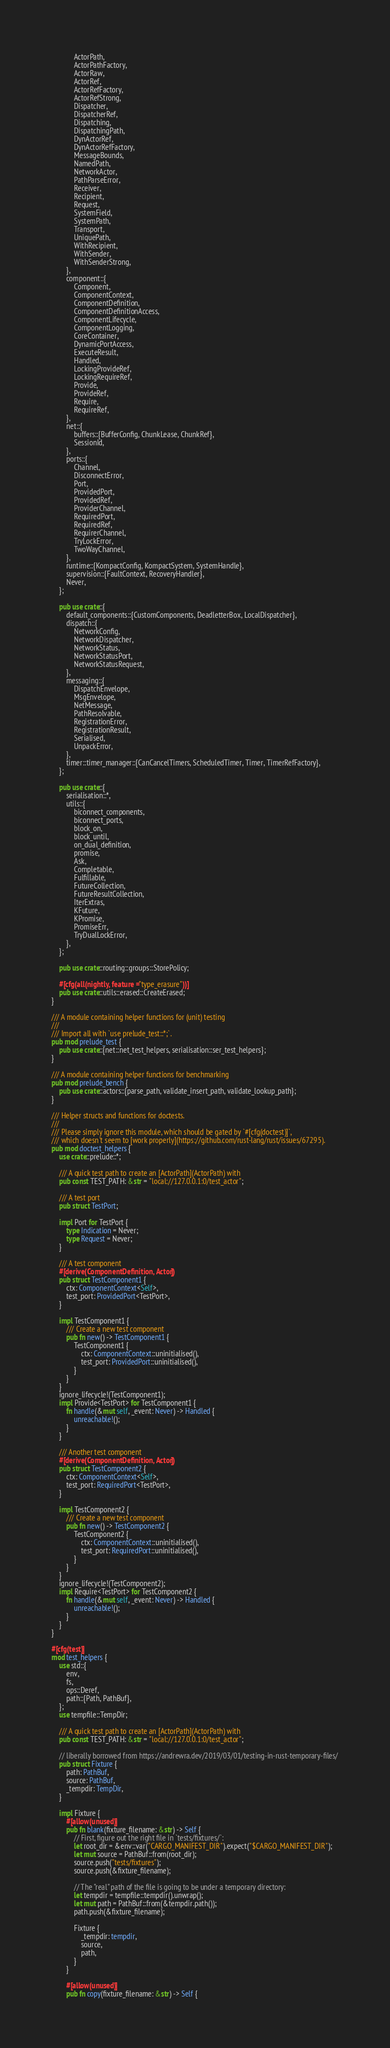<code> <loc_0><loc_0><loc_500><loc_500><_Rust_>            ActorPath,
            ActorPathFactory,
            ActorRaw,
            ActorRef,
            ActorRefFactory,
            ActorRefStrong,
            Dispatcher,
            DispatcherRef,
            Dispatching,
            DispatchingPath,
            DynActorRef,
            DynActorRefFactory,
            MessageBounds,
            NamedPath,
            NetworkActor,
            PathParseError,
            Receiver,
            Recipient,
            Request,
            SystemField,
            SystemPath,
            Transport,
            UniquePath,
            WithRecipient,
            WithSender,
            WithSenderStrong,
        },
        component::{
            Component,
            ComponentContext,
            ComponentDefinition,
            ComponentDefinitionAccess,
            ComponentLifecycle,
            ComponentLogging,
            CoreContainer,
            DynamicPortAccess,
            ExecuteResult,
            Handled,
            LockingProvideRef,
            LockingRequireRef,
            Provide,
            ProvideRef,
            Require,
            RequireRef,
        },
        net::{
            buffers::{BufferConfig, ChunkLease, ChunkRef},
            SessionId,
        },
        ports::{
            Channel,
            DisconnectError,
            Port,
            ProvidedPort,
            ProvidedRef,
            ProviderChannel,
            RequiredPort,
            RequiredRef,
            RequirerChannel,
            TryLockError,
            TwoWayChannel,
        },
        runtime::{KompactConfig, KompactSystem, SystemHandle},
        supervision::{FaultContext, RecoveryHandler},
        Never,
    };

    pub use crate::{
        default_components::{CustomComponents, DeadletterBox, LocalDispatcher},
        dispatch::{
            NetworkConfig,
            NetworkDispatcher,
            NetworkStatus,
            NetworkStatusPort,
            NetworkStatusRequest,
        },
        messaging::{
            DispatchEnvelope,
            MsgEnvelope,
            NetMessage,
            PathResolvable,
            RegistrationError,
            RegistrationResult,
            Serialised,
            UnpackError,
        },
        timer::timer_manager::{CanCancelTimers, ScheduledTimer, Timer, TimerRefFactory},
    };

    pub use crate::{
        serialisation::*,
        utils::{
            biconnect_components,
            biconnect_ports,
            block_on,
            block_until,
            on_dual_definition,
            promise,
            Ask,
            Completable,
            Fulfillable,
            FutureCollection,
            FutureResultCollection,
            IterExtras,
            KFuture,
            KPromise,
            PromiseErr,
            TryDualLockError,
        },
    };

    pub use crate::routing::groups::StorePolicy;

    #[cfg(all(nightly, feature = "type_erasure"))]
    pub use crate::utils::erased::CreateErased;
}

/// A module containing helper functions for (unit) testing
///
/// Import all with `use prelude_test::*;`.
pub mod prelude_test {
    pub use crate::{net::net_test_helpers, serialisation::ser_test_helpers};
}

/// A module containing helper functions for benchmarking
pub mod prelude_bench {
    pub use crate::actors::{parse_path, validate_insert_path, validate_lookup_path};
}

/// Helper structs and functions for doctests.
///
/// Please simply ignore this module, which should be gated by `#[cfg(doctest)]`,
/// which doesn't seem to [work properly](https://github.com/rust-lang/rust/issues/67295).
pub mod doctest_helpers {
    use crate::prelude::*;

    /// A quick test path to create an [ActorPath](ActorPath) with
    pub const TEST_PATH: &str = "local://127.0.0.1:0/test_actor";

    /// A test port
    pub struct TestPort;

    impl Port for TestPort {
        type Indication = Never;
        type Request = Never;
    }

    /// A test component
    #[derive(ComponentDefinition, Actor)]
    pub struct TestComponent1 {
        ctx: ComponentContext<Self>,
        test_port: ProvidedPort<TestPort>,
    }

    impl TestComponent1 {
        /// Create a new test component
        pub fn new() -> TestComponent1 {
            TestComponent1 {
                ctx: ComponentContext::uninitialised(),
                test_port: ProvidedPort::uninitialised(),
            }
        }
    }
    ignore_lifecycle!(TestComponent1);
    impl Provide<TestPort> for TestComponent1 {
        fn handle(&mut self, _event: Never) -> Handled {
            unreachable!();
        }
    }

    /// Another test component
    #[derive(ComponentDefinition, Actor)]
    pub struct TestComponent2 {
        ctx: ComponentContext<Self>,
        test_port: RequiredPort<TestPort>,
    }

    impl TestComponent2 {
        /// Create a new test component
        pub fn new() -> TestComponent2 {
            TestComponent2 {
                ctx: ComponentContext::uninitialised(),
                test_port: RequiredPort::uninitialised(),
            }
        }
    }
    ignore_lifecycle!(TestComponent2);
    impl Require<TestPort> for TestComponent2 {
        fn handle(&mut self, _event: Never) -> Handled {
            unreachable!();
        }
    }
}

#[cfg(test)]
mod test_helpers {
    use std::{
        env,
        fs,
        ops::Deref,
        path::{Path, PathBuf},
    };
    use tempfile::TempDir;

    /// A quick test path to create an [ActorPath](ActorPath) with
    pub const TEST_PATH: &str = "local://127.0.0.1:0/test_actor";

    // liberally borrowed from https://andrewra.dev/2019/03/01/testing-in-rust-temporary-files/
    pub struct Fixture {
        path: PathBuf,
        source: PathBuf,
        _tempdir: TempDir,
    }

    impl Fixture {
        #[allow(unused)]
        pub fn blank(fixture_filename: &str) -> Self {
            // First, figure out the right file in `tests/fixtures/`:
            let root_dir = &env::var("CARGO_MANIFEST_DIR").expect("$CARGO_MANIFEST_DIR");
            let mut source = PathBuf::from(root_dir);
            source.push("tests/fixtures");
            source.push(&fixture_filename);

            // The "real" path of the file is going to be under a temporary directory:
            let tempdir = tempfile::tempdir().unwrap();
            let mut path = PathBuf::from(&tempdir.path());
            path.push(&fixture_filename);

            Fixture {
                _tempdir: tempdir,
                source,
                path,
            }
        }

        #[allow(unused)]
        pub fn copy(fixture_filename: &str) -> Self {</code> 